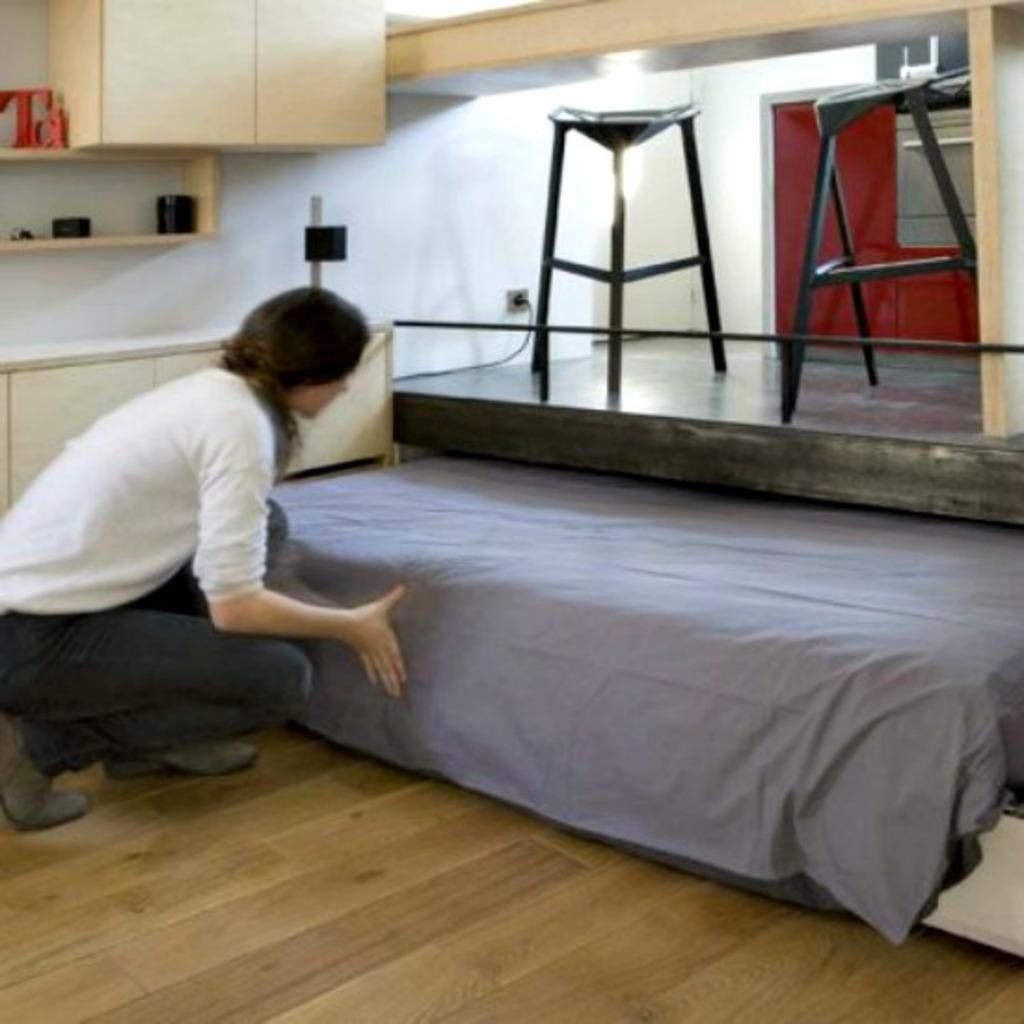What piece of furniture is present in the image? There is a bed in the image. What is the woman in the image doing? The woman is pushing the bed. What type of seating is visible in the image? There are two stools in the image. What storage unit can be seen in the image? There is a cupboard in the image. Can you see a ghost flying above the bed in the image? No, there is no ghost present in the image. 